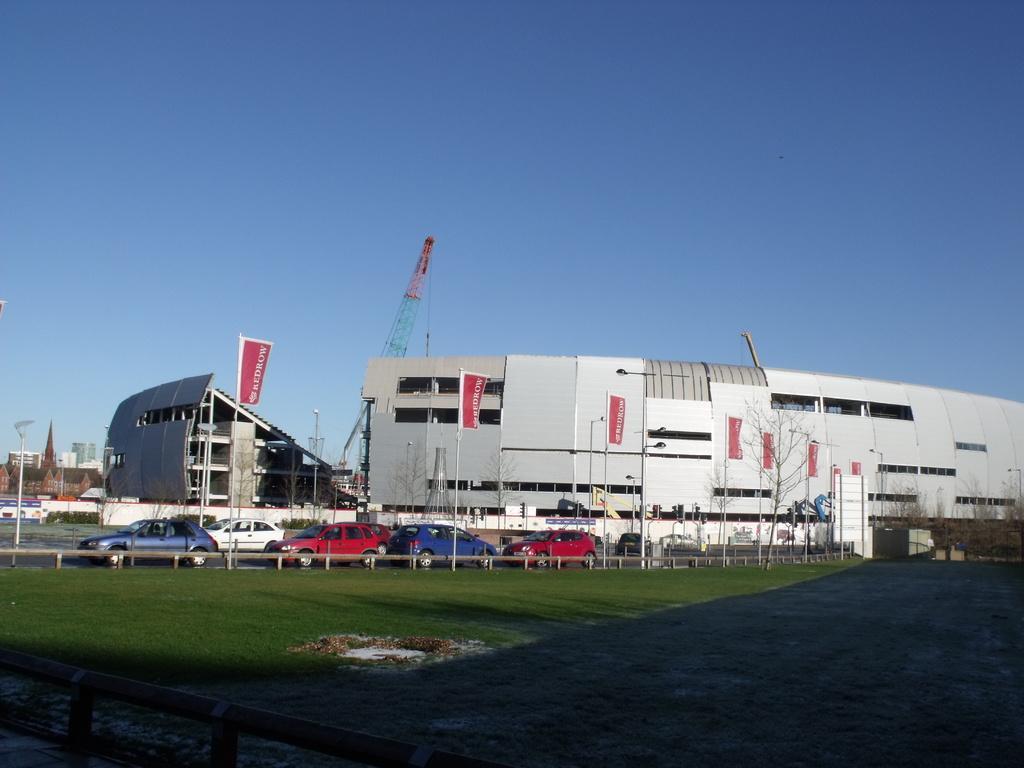Please provide a concise description of this image. In this image I can see the ground, some grass on the ground and few vehicles on the road. In the background I can see few trees, few poles, few buildings, a crane and the sky. 